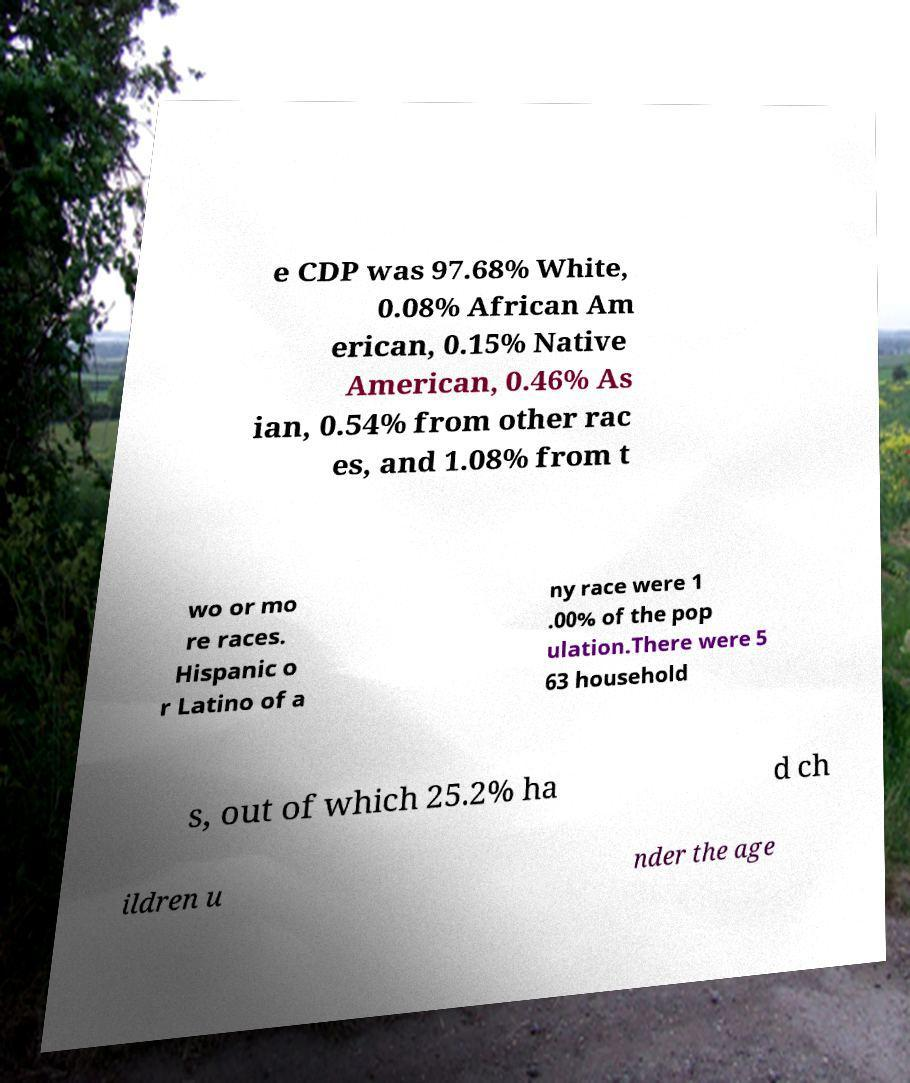I need the written content from this picture converted into text. Can you do that? e CDP was 97.68% White, 0.08% African Am erican, 0.15% Native American, 0.46% As ian, 0.54% from other rac es, and 1.08% from t wo or mo re races. Hispanic o r Latino of a ny race were 1 .00% of the pop ulation.There were 5 63 household s, out of which 25.2% ha d ch ildren u nder the age 